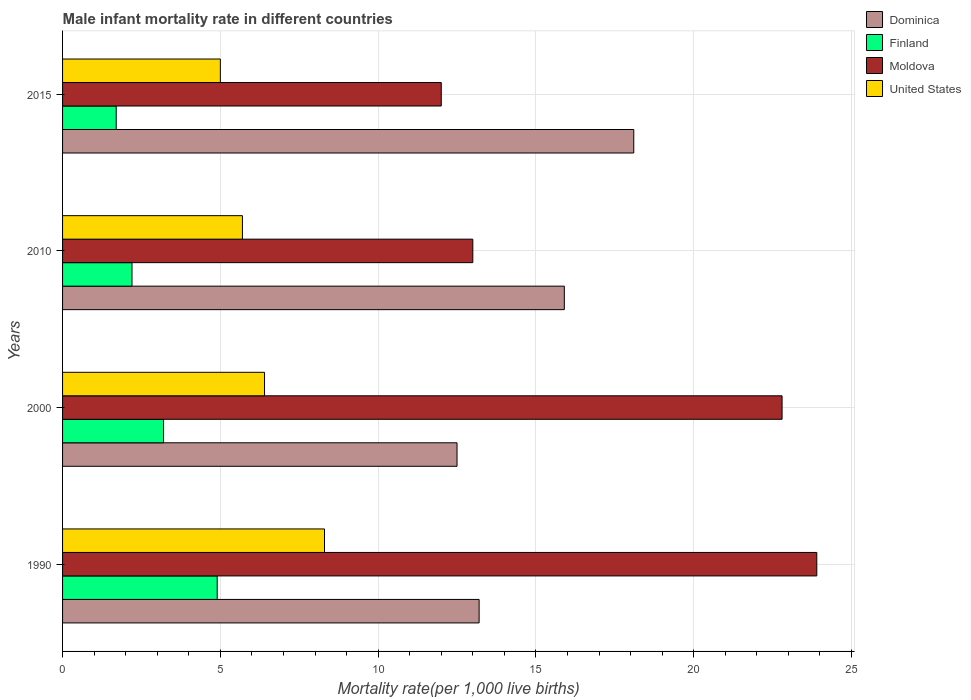How many different coloured bars are there?
Ensure brevity in your answer.  4. How many bars are there on the 1st tick from the bottom?
Provide a succinct answer. 4. In which year was the male infant mortality rate in Finland maximum?
Your answer should be compact. 1990. In which year was the male infant mortality rate in Moldova minimum?
Make the answer very short. 2015. What is the total male infant mortality rate in Moldova in the graph?
Ensure brevity in your answer.  71.7. What is the difference between the male infant mortality rate in Moldova in 1990 and that in 2000?
Provide a short and direct response. 1.1. What is the difference between the male infant mortality rate in United States in 2010 and the male infant mortality rate in Moldova in 2000?
Keep it short and to the point. -17.1. What is the average male infant mortality rate in Moldova per year?
Keep it short and to the point. 17.93. In the year 2010, what is the difference between the male infant mortality rate in Dominica and male infant mortality rate in Finland?
Ensure brevity in your answer.  13.7. In how many years, is the male infant mortality rate in Finland greater than 18 ?
Your answer should be very brief. 0. What is the ratio of the male infant mortality rate in Dominica in 1990 to that in 2000?
Offer a very short reply. 1.06. What is the difference between the highest and the second highest male infant mortality rate in United States?
Keep it short and to the point. 1.9. In how many years, is the male infant mortality rate in Finland greater than the average male infant mortality rate in Finland taken over all years?
Make the answer very short. 2. Is the sum of the male infant mortality rate in Dominica in 1990 and 2010 greater than the maximum male infant mortality rate in Moldova across all years?
Provide a short and direct response. Yes. Is it the case that in every year, the sum of the male infant mortality rate in United States and male infant mortality rate in Finland is greater than the sum of male infant mortality rate in Dominica and male infant mortality rate in Moldova?
Give a very brief answer. No. What does the 2nd bar from the top in 2000 represents?
Give a very brief answer. Moldova. What does the 3rd bar from the bottom in 1990 represents?
Provide a succinct answer. Moldova. Is it the case that in every year, the sum of the male infant mortality rate in Finland and male infant mortality rate in United States is greater than the male infant mortality rate in Moldova?
Ensure brevity in your answer.  No. How many bars are there?
Make the answer very short. 16. How many years are there in the graph?
Provide a succinct answer. 4. Are the values on the major ticks of X-axis written in scientific E-notation?
Provide a short and direct response. No. How many legend labels are there?
Your response must be concise. 4. How are the legend labels stacked?
Provide a succinct answer. Vertical. What is the title of the graph?
Offer a very short reply. Male infant mortality rate in different countries. What is the label or title of the X-axis?
Offer a very short reply. Mortality rate(per 1,0 live births). What is the Mortality rate(per 1,000 live births) of Dominica in 1990?
Provide a short and direct response. 13.2. What is the Mortality rate(per 1,000 live births) in Finland in 1990?
Offer a terse response. 4.9. What is the Mortality rate(per 1,000 live births) in Moldova in 1990?
Provide a succinct answer. 23.9. What is the Mortality rate(per 1,000 live births) of Finland in 2000?
Offer a terse response. 3.2. What is the Mortality rate(per 1,000 live births) in Moldova in 2000?
Give a very brief answer. 22.8. What is the Mortality rate(per 1,000 live births) of United States in 2010?
Keep it short and to the point. 5.7. What is the Mortality rate(per 1,000 live births) in Finland in 2015?
Make the answer very short. 1.7. Across all years, what is the maximum Mortality rate(per 1,000 live births) of Finland?
Ensure brevity in your answer.  4.9. Across all years, what is the maximum Mortality rate(per 1,000 live births) in Moldova?
Make the answer very short. 23.9. Across all years, what is the maximum Mortality rate(per 1,000 live births) in United States?
Offer a terse response. 8.3. Across all years, what is the minimum Mortality rate(per 1,000 live births) of Dominica?
Offer a very short reply. 12.5. Across all years, what is the minimum Mortality rate(per 1,000 live births) of Finland?
Keep it short and to the point. 1.7. What is the total Mortality rate(per 1,000 live births) of Dominica in the graph?
Provide a short and direct response. 59.7. What is the total Mortality rate(per 1,000 live births) in Moldova in the graph?
Your answer should be compact. 71.7. What is the total Mortality rate(per 1,000 live births) of United States in the graph?
Provide a succinct answer. 25.4. What is the difference between the Mortality rate(per 1,000 live births) of Finland in 1990 and that in 2000?
Ensure brevity in your answer.  1.7. What is the difference between the Mortality rate(per 1,000 live births) in Moldova in 1990 and that in 2000?
Your response must be concise. 1.1. What is the difference between the Mortality rate(per 1,000 live births) of United States in 1990 and that in 2000?
Your answer should be very brief. 1.9. What is the difference between the Mortality rate(per 1,000 live births) in Finland in 1990 and that in 2010?
Your response must be concise. 2.7. What is the difference between the Mortality rate(per 1,000 live births) in Finland in 1990 and that in 2015?
Give a very brief answer. 3.2. What is the difference between the Mortality rate(per 1,000 live births) in Moldova in 1990 and that in 2015?
Make the answer very short. 11.9. What is the difference between the Mortality rate(per 1,000 live births) in United States in 1990 and that in 2015?
Offer a terse response. 3.3. What is the difference between the Mortality rate(per 1,000 live births) in Finland in 2000 and that in 2010?
Ensure brevity in your answer.  1. What is the difference between the Mortality rate(per 1,000 live births) of Moldova in 2000 and that in 2010?
Give a very brief answer. 9.8. What is the difference between the Mortality rate(per 1,000 live births) in Dominica in 2000 and that in 2015?
Make the answer very short. -5.6. What is the difference between the Mortality rate(per 1,000 live births) of Moldova in 2010 and that in 2015?
Provide a short and direct response. 1. What is the difference between the Mortality rate(per 1,000 live births) of Dominica in 1990 and the Mortality rate(per 1,000 live births) of Finland in 2000?
Provide a short and direct response. 10. What is the difference between the Mortality rate(per 1,000 live births) in Finland in 1990 and the Mortality rate(per 1,000 live births) in Moldova in 2000?
Give a very brief answer. -17.9. What is the difference between the Mortality rate(per 1,000 live births) of Finland in 1990 and the Mortality rate(per 1,000 live births) of United States in 2000?
Offer a terse response. -1.5. What is the difference between the Mortality rate(per 1,000 live births) of Moldova in 1990 and the Mortality rate(per 1,000 live births) of United States in 2000?
Ensure brevity in your answer.  17.5. What is the difference between the Mortality rate(per 1,000 live births) of Finland in 1990 and the Mortality rate(per 1,000 live births) of Moldova in 2010?
Your response must be concise. -8.1. What is the difference between the Mortality rate(per 1,000 live births) in Finland in 1990 and the Mortality rate(per 1,000 live births) in United States in 2010?
Give a very brief answer. -0.8. What is the difference between the Mortality rate(per 1,000 live births) of Dominica in 1990 and the Mortality rate(per 1,000 live births) of Finland in 2015?
Your response must be concise. 11.5. What is the difference between the Mortality rate(per 1,000 live births) in Moldova in 1990 and the Mortality rate(per 1,000 live births) in United States in 2015?
Provide a short and direct response. 18.9. What is the difference between the Mortality rate(per 1,000 live births) of Dominica in 2000 and the Mortality rate(per 1,000 live births) of United States in 2010?
Keep it short and to the point. 6.8. What is the difference between the Mortality rate(per 1,000 live births) of Finland in 2000 and the Mortality rate(per 1,000 live births) of Moldova in 2010?
Make the answer very short. -9.8. What is the difference between the Mortality rate(per 1,000 live births) in Finland in 2000 and the Mortality rate(per 1,000 live births) in United States in 2010?
Offer a very short reply. -2.5. What is the difference between the Mortality rate(per 1,000 live births) in Dominica in 2000 and the Mortality rate(per 1,000 live births) in Finland in 2015?
Keep it short and to the point. 10.8. What is the difference between the Mortality rate(per 1,000 live births) of Finland in 2000 and the Mortality rate(per 1,000 live births) of Moldova in 2015?
Provide a short and direct response. -8.8. What is the difference between the Mortality rate(per 1,000 live births) in Finland in 2000 and the Mortality rate(per 1,000 live births) in United States in 2015?
Ensure brevity in your answer.  -1.8. What is the difference between the Mortality rate(per 1,000 live births) of Dominica in 2010 and the Mortality rate(per 1,000 live births) of Finland in 2015?
Offer a very short reply. 14.2. What is the difference between the Mortality rate(per 1,000 live births) in Dominica in 2010 and the Mortality rate(per 1,000 live births) in United States in 2015?
Provide a succinct answer. 10.9. What is the difference between the Mortality rate(per 1,000 live births) in Finland in 2010 and the Mortality rate(per 1,000 live births) in United States in 2015?
Your answer should be compact. -2.8. What is the difference between the Mortality rate(per 1,000 live births) of Moldova in 2010 and the Mortality rate(per 1,000 live births) of United States in 2015?
Offer a terse response. 8. What is the average Mortality rate(per 1,000 live births) of Dominica per year?
Offer a very short reply. 14.93. What is the average Mortality rate(per 1,000 live births) in Finland per year?
Your answer should be very brief. 3. What is the average Mortality rate(per 1,000 live births) of Moldova per year?
Provide a short and direct response. 17.93. What is the average Mortality rate(per 1,000 live births) in United States per year?
Offer a terse response. 6.35. In the year 1990, what is the difference between the Mortality rate(per 1,000 live births) in Dominica and Mortality rate(per 1,000 live births) in United States?
Offer a very short reply. 4.9. In the year 1990, what is the difference between the Mortality rate(per 1,000 live births) in Finland and Mortality rate(per 1,000 live births) in United States?
Your answer should be compact. -3.4. In the year 2000, what is the difference between the Mortality rate(per 1,000 live births) of Dominica and Mortality rate(per 1,000 live births) of United States?
Make the answer very short. 6.1. In the year 2000, what is the difference between the Mortality rate(per 1,000 live births) in Finland and Mortality rate(per 1,000 live births) in Moldova?
Give a very brief answer. -19.6. In the year 2000, what is the difference between the Mortality rate(per 1,000 live births) of Moldova and Mortality rate(per 1,000 live births) of United States?
Ensure brevity in your answer.  16.4. In the year 2010, what is the difference between the Mortality rate(per 1,000 live births) of Dominica and Mortality rate(per 1,000 live births) of Finland?
Offer a terse response. 13.7. In the year 2010, what is the difference between the Mortality rate(per 1,000 live births) of Dominica and Mortality rate(per 1,000 live births) of Moldova?
Make the answer very short. 2.9. In the year 2010, what is the difference between the Mortality rate(per 1,000 live births) of Dominica and Mortality rate(per 1,000 live births) of United States?
Keep it short and to the point. 10.2. In the year 2010, what is the difference between the Mortality rate(per 1,000 live births) of Finland and Mortality rate(per 1,000 live births) of Moldova?
Your response must be concise. -10.8. In the year 2010, what is the difference between the Mortality rate(per 1,000 live births) of Moldova and Mortality rate(per 1,000 live births) of United States?
Your response must be concise. 7.3. In the year 2015, what is the difference between the Mortality rate(per 1,000 live births) of Dominica and Mortality rate(per 1,000 live births) of Finland?
Offer a very short reply. 16.4. In the year 2015, what is the difference between the Mortality rate(per 1,000 live births) in Dominica and Mortality rate(per 1,000 live births) in Moldova?
Provide a short and direct response. 6.1. In the year 2015, what is the difference between the Mortality rate(per 1,000 live births) of Finland and Mortality rate(per 1,000 live births) of United States?
Give a very brief answer. -3.3. What is the ratio of the Mortality rate(per 1,000 live births) in Dominica in 1990 to that in 2000?
Your answer should be very brief. 1.06. What is the ratio of the Mortality rate(per 1,000 live births) of Finland in 1990 to that in 2000?
Give a very brief answer. 1.53. What is the ratio of the Mortality rate(per 1,000 live births) in Moldova in 1990 to that in 2000?
Give a very brief answer. 1.05. What is the ratio of the Mortality rate(per 1,000 live births) of United States in 1990 to that in 2000?
Offer a very short reply. 1.3. What is the ratio of the Mortality rate(per 1,000 live births) of Dominica in 1990 to that in 2010?
Your answer should be very brief. 0.83. What is the ratio of the Mortality rate(per 1,000 live births) of Finland in 1990 to that in 2010?
Offer a terse response. 2.23. What is the ratio of the Mortality rate(per 1,000 live births) of Moldova in 1990 to that in 2010?
Provide a short and direct response. 1.84. What is the ratio of the Mortality rate(per 1,000 live births) in United States in 1990 to that in 2010?
Give a very brief answer. 1.46. What is the ratio of the Mortality rate(per 1,000 live births) of Dominica in 1990 to that in 2015?
Keep it short and to the point. 0.73. What is the ratio of the Mortality rate(per 1,000 live births) in Finland in 1990 to that in 2015?
Make the answer very short. 2.88. What is the ratio of the Mortality rate(per 1,000 live births) of Moldova in 1990 to that in 2015?
Provide a succinct answer. 1.99. What is the ratio of the Mortality rate(per 1,000 live births) of United States in 1990 to that in 2015?
Keep it short and to the point. 1.66. What is the ratio of the Mortality rate(per 1,000 live births) in Dominica in 2000 to that in 2010?
Provide a succinct answer. 0.79. What is the ratio of the Mortality rate(per 1,000 live births) in Finland in 2000 to that in 2010?
Make the answer very short. 1.45. What is the ratio of the Mortality rate(per 1,000 live births) in Moldova in 2000 to that in 2010?
Provide a short and direct response. 1.75. What is the ratio of the Mortality rate(per 1,000 live births) of United States in 2000 to that in 2010?
Keep it short and to the point. 1.12. What is the ratio of the Mortality rate(per 1,000 live births) of Dominica in 2000 to that in 2015?
Provide a short and direct response. 0.69. What is the ratio of the Mortality rate(per 1,000 live births) in Finland in 2000 to that in 2015?
Provide a short and direct response. 1.88. What is the ratio of the Mortality rate(per 1,000 live births) in Moldova in 2000 to that in 2015?
Offer a terse response. 1.9. What is the ratio of the Mortality rate(per 1,000 live births) of United States in 2000 to that in 2015?
Provide a short and direct response. 1.28. What is the ratio of the Mortality rate(per 1,000 live births) in Dominica in 2010 to that in 2015?
Offer a terse response. 0.88. What is the ratio of the Mortality rate(per 1,000 live births) of Finland in 2010 to that in 2015?
Make the answer very short. 1.29. What is the ratio of the Mortality rate(per 1,000 live births) in United States in 2010 to that in 2015?
Make the answer very short. 1.14. What is the difference between the highest and the second highest Mortality rate(per 1,000 live births) of Dominica?
Your answer should be compact. 2.2. What is the difference between the highest and the second highest Mortality rate(per 1,000 live births) of Finland?
Make the answer very short. 1.7. What is the difference between the highest and the second highest Mortality rate(per 1,000 live births) in Moldova?
Give a very brief answer. 1.1. What is the difference between the highest and the lowest Mortality rate(per 1,000 live births) in Dominica?
Offer a very short reply. 5.6. What is the difference between the highest and the lowest Mortality rate(per 1,000 live births) of Moldova?
Provide a succinct answer. 11.9. What is the difference between the highest and the lowest Mortality rate(per 1,000 live births) of United States?
Make the answer very short. 3.3. 